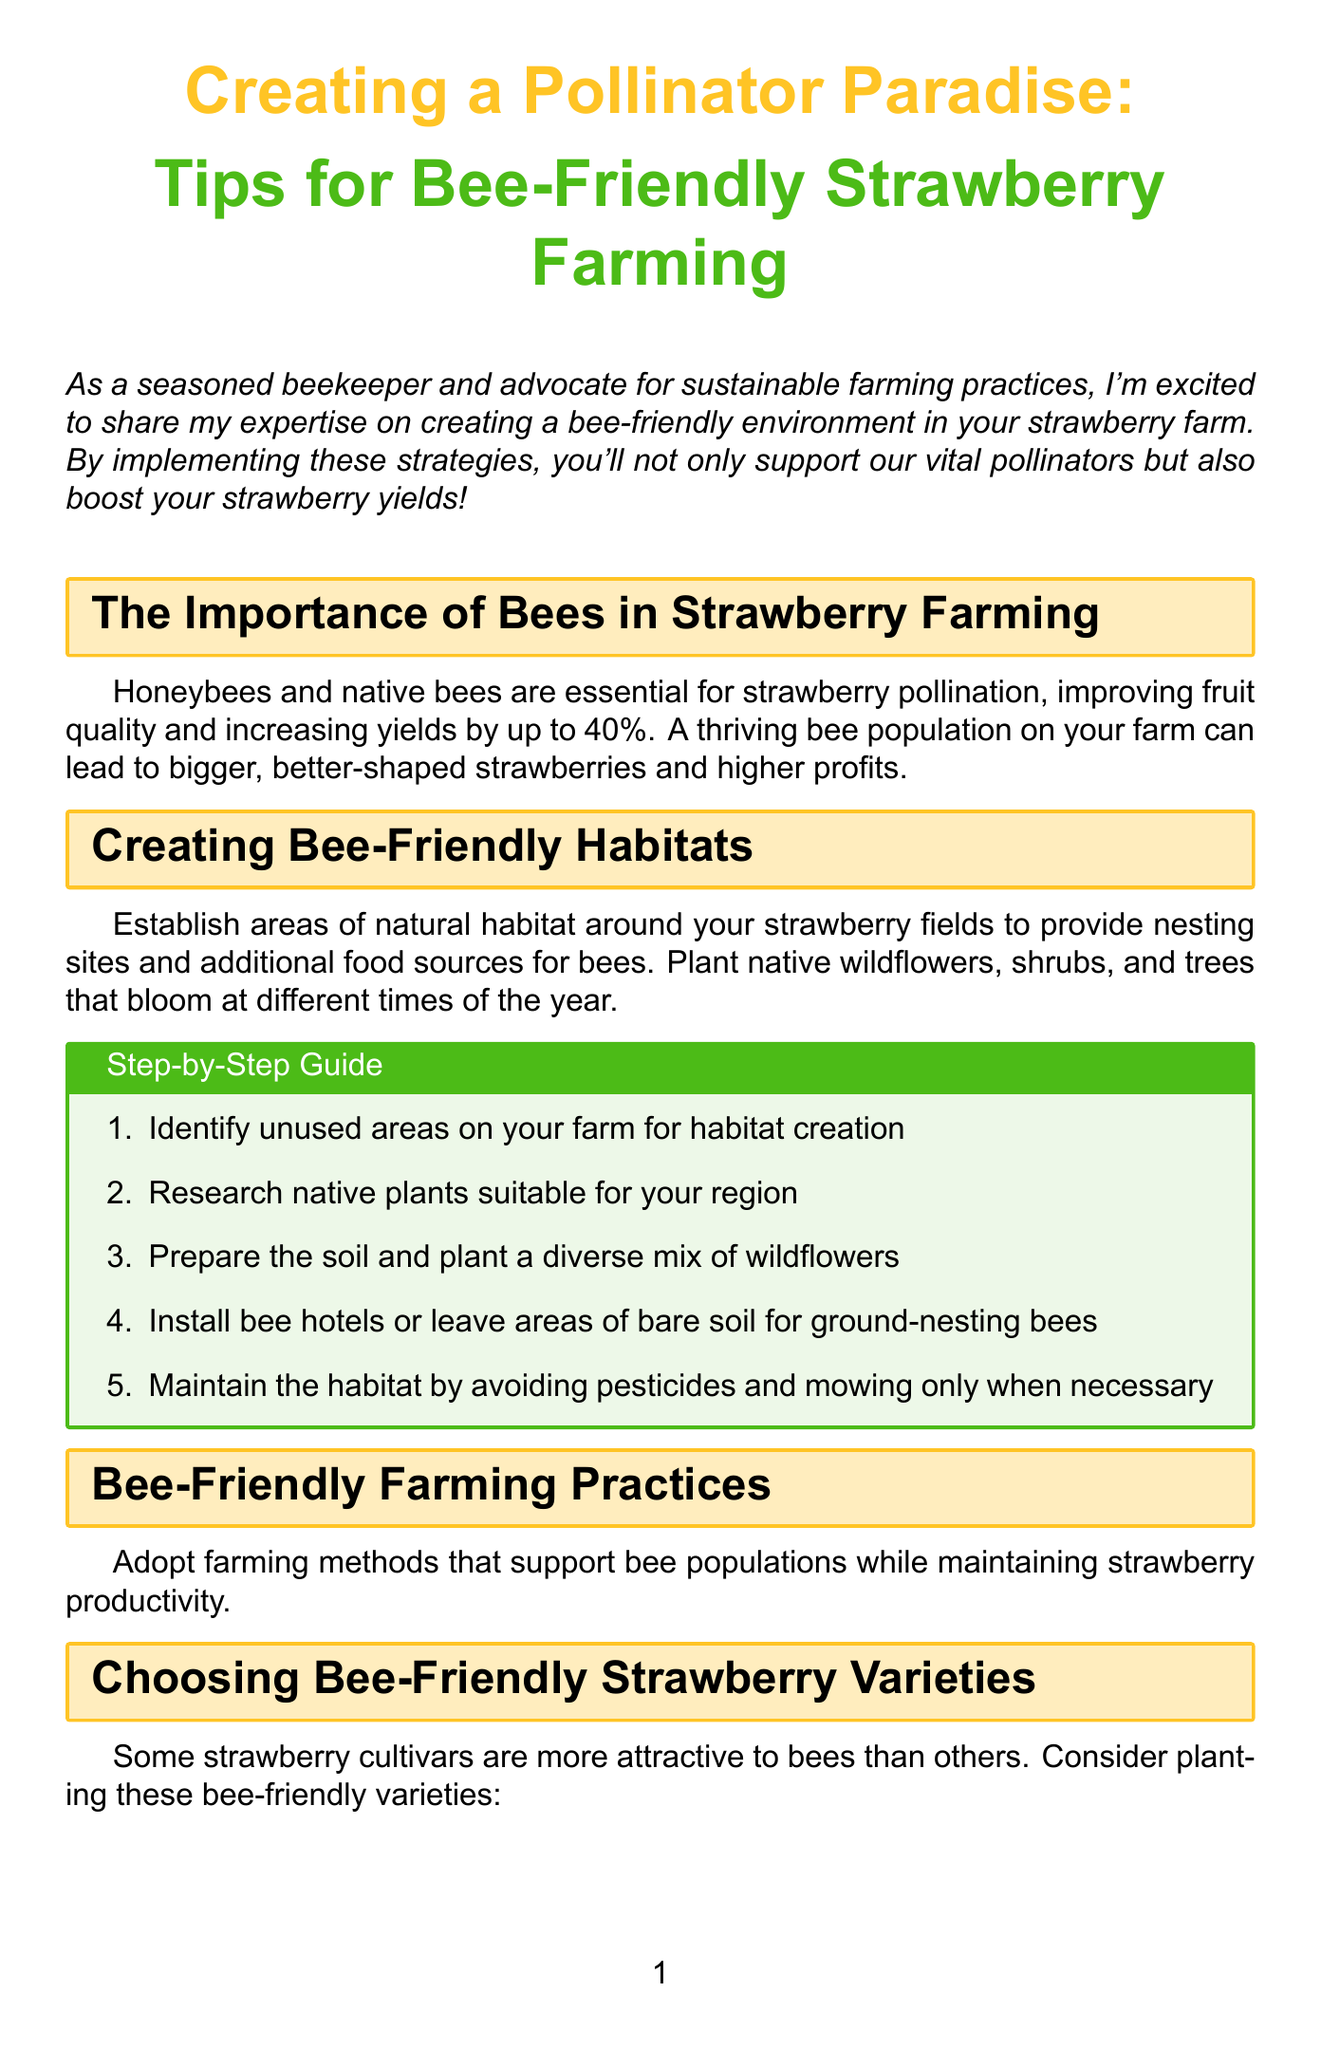What is the newsletter title? The title will provide the primary focus of the newsletter, which is about creating a bee-friendly environment for farming strawberries.
Answer: Creating a Pollinator Paradise: Tips for Bee-Friendly Strawberry Farming How much can bee pollination increase strawberry yields? This is found in the section discussing the importance of bees, which indicates the impact of bee pollination on strawberry yields.
Answer: up to 40% Name one bee-friendly strawberry variety. The document lists several varieties that are attractive to bees; picking any one will be correct.
Answer: Honeoye What should you avoid to maintain bee-friendly habitats? The advice given for maintaining bee habitats highlights practices that would harm the bees.
Answer: pesticides How many hives are recommended per acre of strawberries? This number is stated in the section on integrating beehives into your farm, detailing optimal hive placement and quantity.
Answer: 2-4 hives What is the purpose of installing bee hotels? This comes from the section about creating bee-friendly habitats, explaining the necessity of certain installations.
Answer: nesting sites What is the role of native plants in the farming strategy? The document emphasizes the importance of planting native plants for ecological support and enhancing bee habitats.
Answer: food sources What period does the 'Seascape' strawberry variety bloom? This detail is answered in the section that lists bee-friendly strawberry varieties, specifying the characteristic of 'Seascape.'
Answer: extended flowering period 